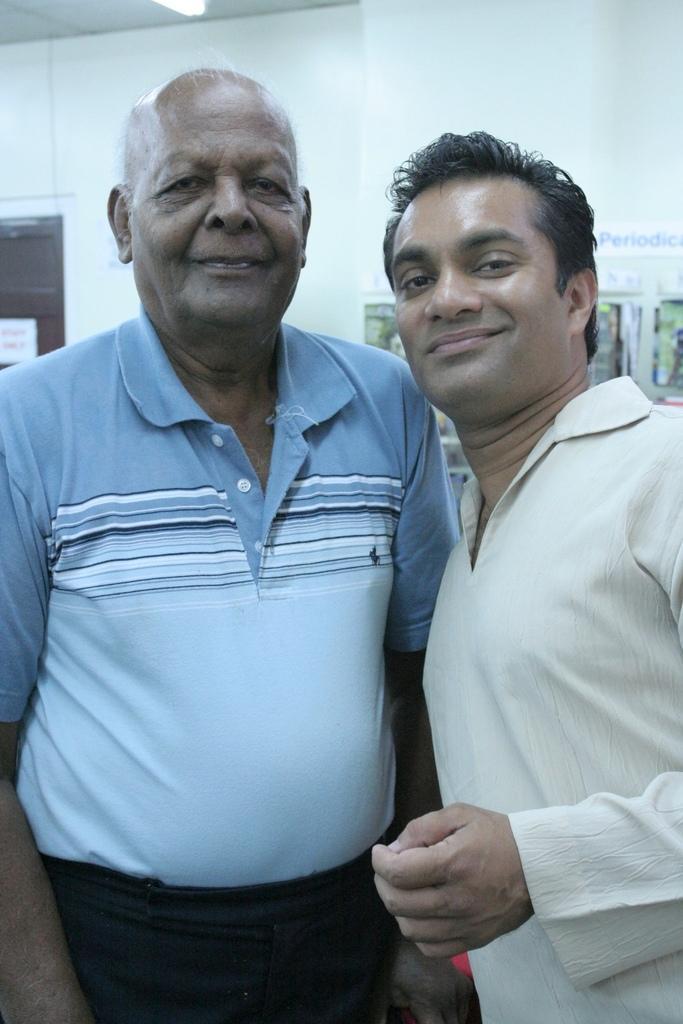Could you give a brief overview of what you see in this image? This image is taken indoors. In the background there is a wall with a window. There are a few posts and boards with a text on them. At the top of the image there is a ceiling with a light. In the middle of the image two men are standing and they are with smiling faces. 